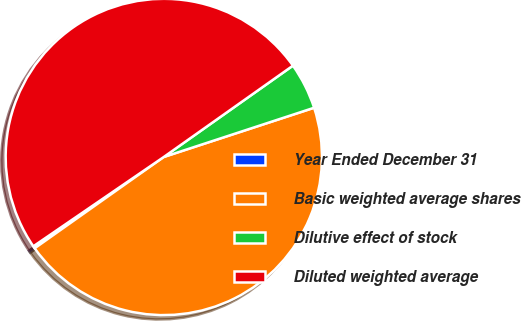Convert chart to OTSL. <chart><loc_0><loc_0><loc_500><loc_500><pie_chart><fcel>Year Ended December 31<fcel>Basic weighted average shares<fcel>Dilutive effect of stock<fcel>Diluted weighted average<nl><fcel>0.24%<fcel>45.24%<fcel>4.76%<fcel>49.76%<nl></chart> 